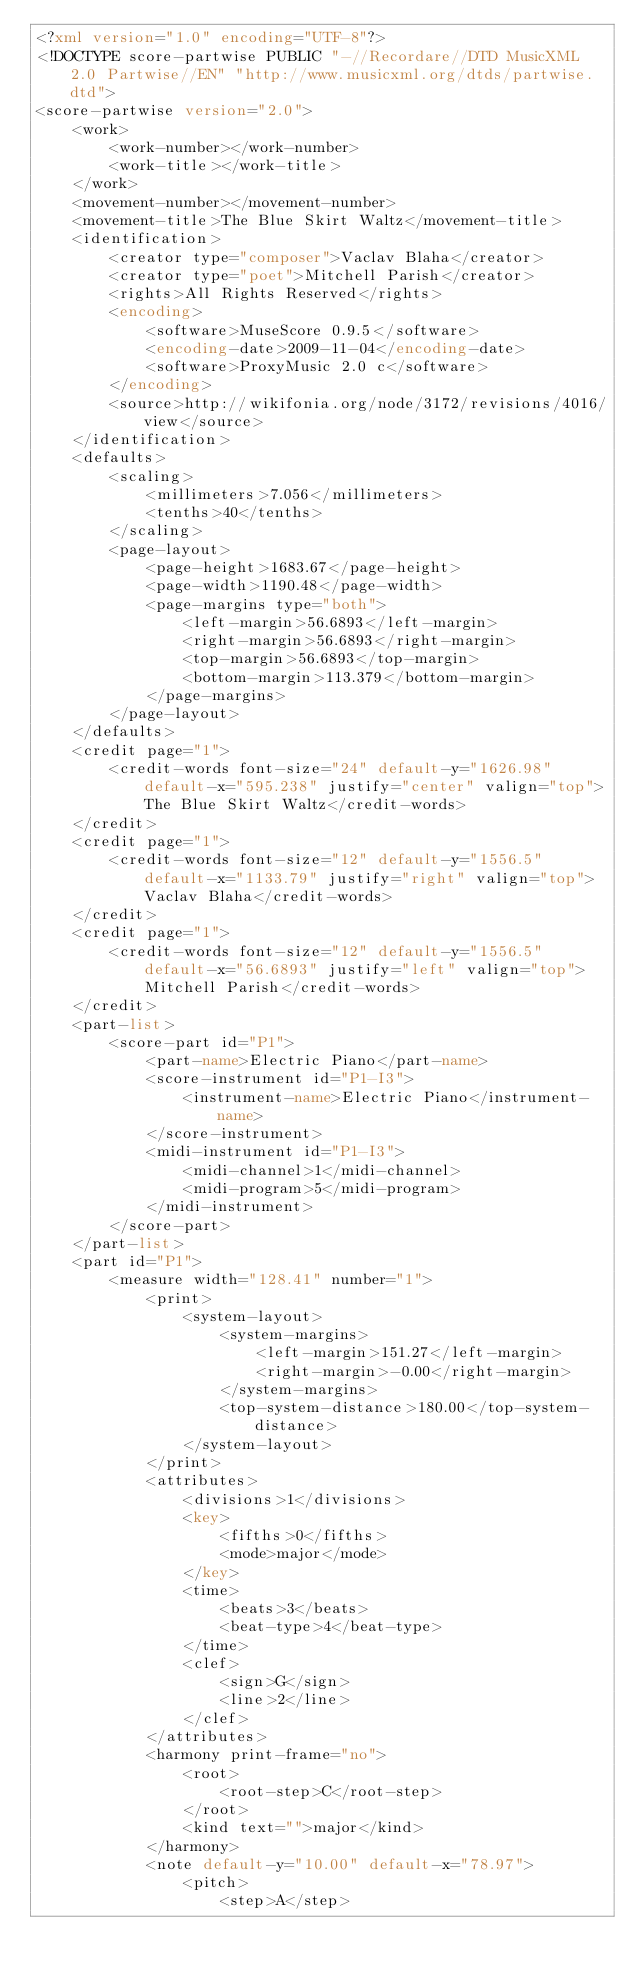Convert code to text. <code><loc_0><loc_0><loc_500><loc_500><_XML_><?xml version="1.0" encoding="UTF-8"?>
<!DOCTYPE score-partwise PUBLIC "-//Recordare//DTD MusicXML 2.0 Partwise//EN" "http://www.musicxml.org/dtds/partwise.dtd">
<score-partwise version="2.0">
    <work>
        <work-number></work-number>
        <work-title></work-title>
    </work>
    <movement-number></movement-number>
    <movement-title>The Blue Skirt Waltz</movement-title>
    <identification>
        <creator type="composer">Vaclav Blaha</creator>
        <creator type="poet">Mitchell Parish</creator>
        <rights>All Rights Reserved</rights>
        <encoding>
            <software>MuseScore 0.9.5</software>
            <encoding-date>2009-11-04</encoding-date>
            <software>ProxyMusic 2.0 c</software>
        </encoding>
        <source>http://wikifonia.org/node/3172/revisions/4016/view</source>
    </identification>
    <defaults>
        <scaling>
            <millimeters>7.056</millimeters>
            <tenths>40</tenths>
        </scaling>
        <page-layout>
            <page-height>1683.67</page-height>
            <page-width>1190.48</page-width>
            <page-margins type="both">
                <left-margin>56.6893</left-margin>
                <right-margin>56.6893</right-margin>
                <top-margin>56.6893</top-margin>
                <bottom-margin>113.379</bottom-margin>
            </page-margins>
        </page-layout>
    </defaults>
    <credit page="1">
        <credit-words font-size="24" default-y="1626.98" default-x="595.238" justify="center" valign="top">The Blue Skirt Waltz</credit-words>
    </credit>
    <credit page="1">
        <credit-words font-size="12" default-y="1556.5" default-x="1133.79" justify="right" valign="top">Vaclav Blaha</credit-words>
    </credit>
    <credit page="1">
        <credit-words font-size="12" default-y="1556.5" default-x="56.6893" justify="left" valign="top">Mitchell Parish</credit-words>
    </credit>
    <part-list>
        <score-part id="P1">
            <part-name>Electric Piano</part-name>
            <score-instrument id="P1-I3">
                <instrument-name>Electric Piano</instrument-name>
            </score-instrument>
            <midi-instrument id="P1-I3">
                <midi-channel>1</midi-channel>
                <midi-program>5</midi-program>
            </midi-instrument>
        </score-part>
    </part-list>
    <part id="P1">
        <measure width="128.41" number="1">
            <print>
                <system-layout>
                    <system-margins>
                        <left-margin>151.27</left-margin>
                        <right-margin>-0.00</right-margin>
                    </system-margins>
                    <top-system-distance>180.00</top-system-distance>
                </system-layout>
            </print>
            <attributes>
                <divisions>1</divisions>
                <key>
                    <fifths>0</fifths>
                    <mode>major</mode>
                </key>
                <time>
                    <beats>3</beats>
                    <beat-type>4</beat-type>
                </time>
                <clef>
                    <sign>G</sign>
                    <line>2</line>
                </clef>
            </attributes>
            <harmony print-frame="no">
                <root>
                    <root-step>C</root-step>
                </root>
                <kind text="">major</kind>
            </harmony>
            <note default-y="10.00" default-x="78.97">
                <pitch>
                    <step>A</step></code> 